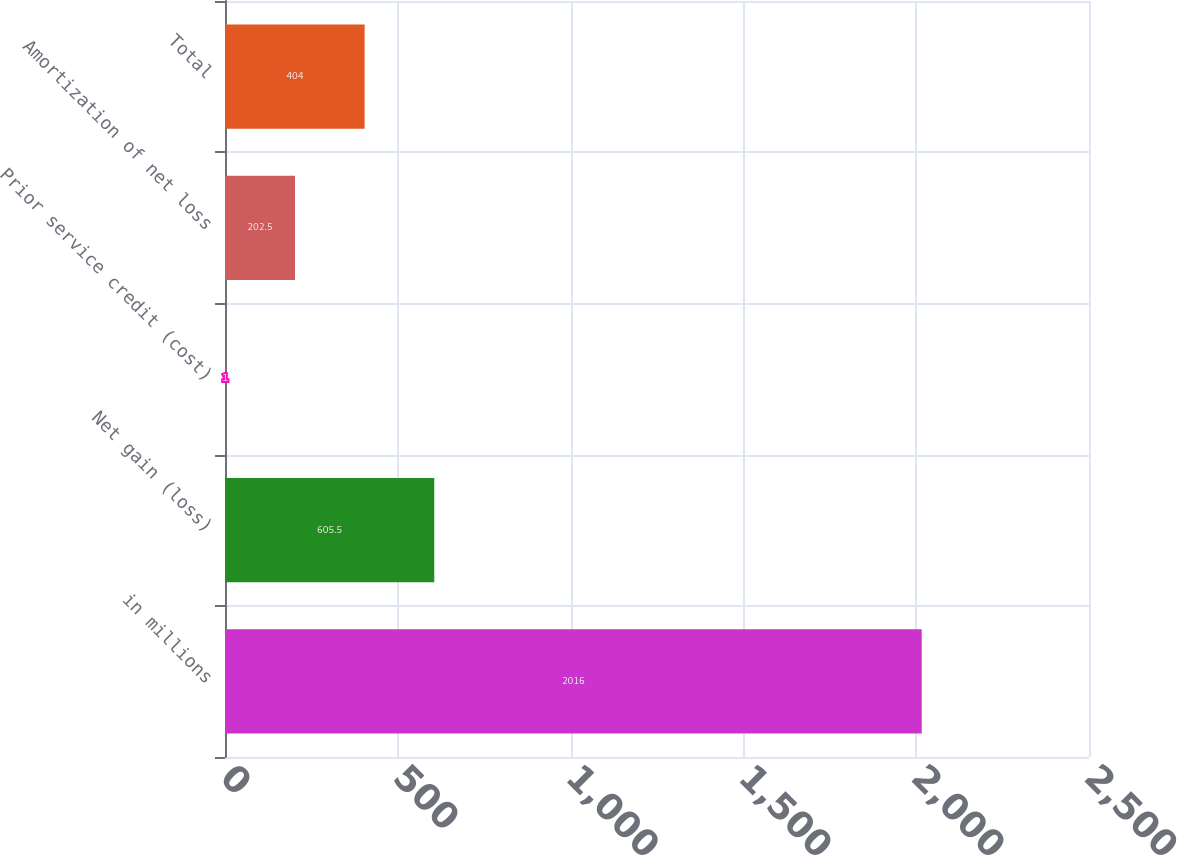<chart> <loc_0><loc_0><loc_500><loc_500><bar_chart><fcel>in millions<fcel>Net gain (loss)<fcel>Prior service credit (cost)<fcel>Amortization of net loss<fcel>Total<nl><fcel>2016<fcel>605.5<fcel>1<fcel>202.5<fcel>404<nl></chart> 